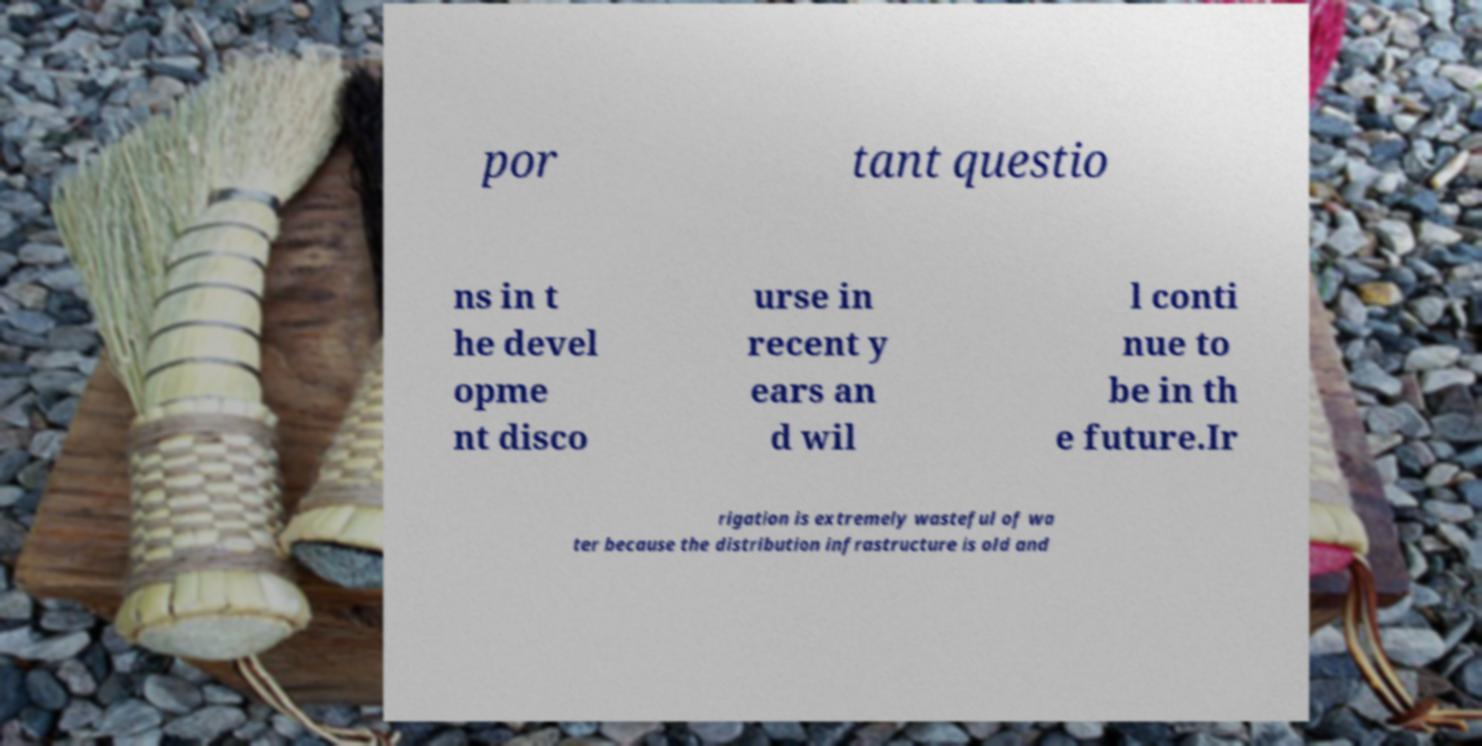Could you assist in decoding the text presented in this image and type it out clearly? por tant questio ns in t he devel opme nt disco urse in recent y ears an d wil l conti nue to be in th e future.Ir rigation is extremely wasteful of wa ter because the distribution infrastructure is old and 